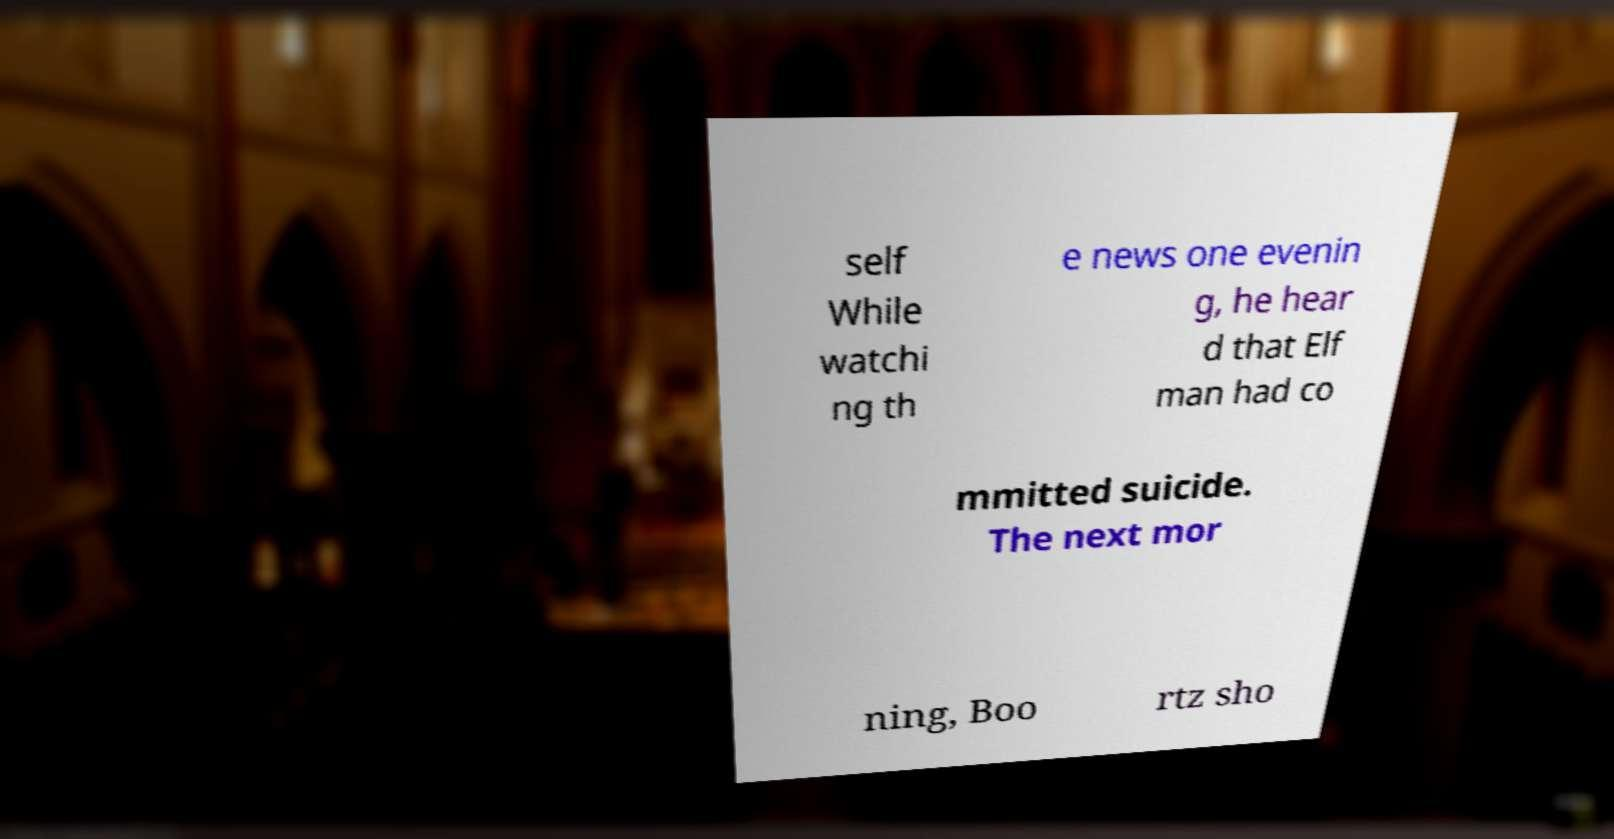Could you extract and type out the text from this image? self While watchi ng th e news one evenin g, he hear d that Elf man had co mmitted suicide. The next mor ning, Boo rtz sho 